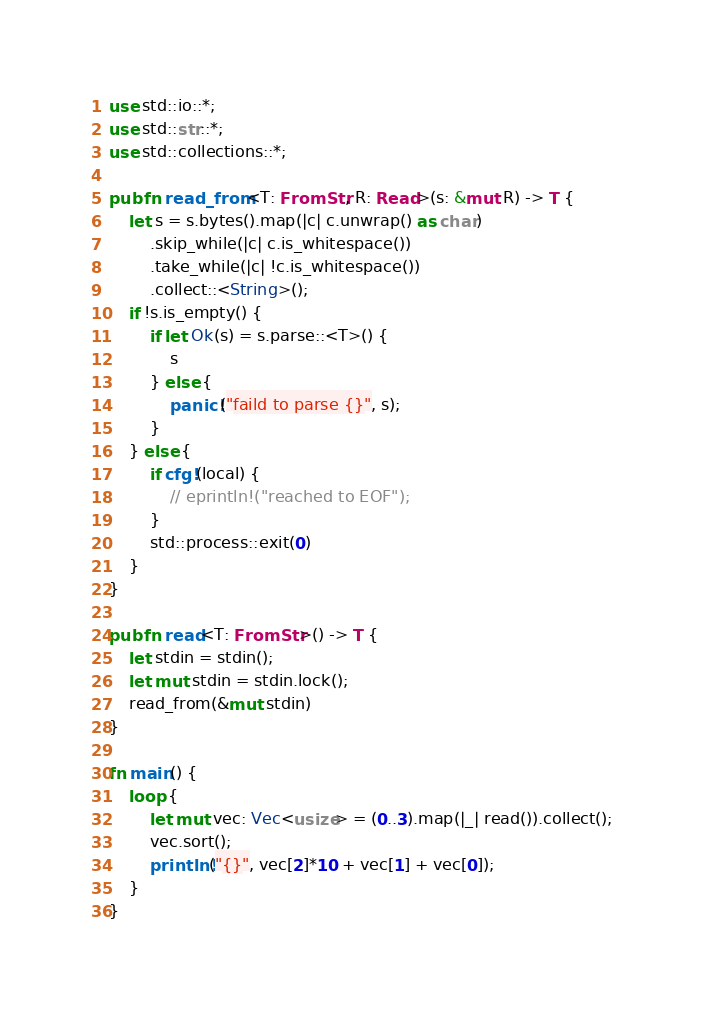Convert code to text. <code><loc_0><loc_0><loc_500><loc_500><_Rust_>use std::io::*;
use std::str::*;
use std::collections::*;

pub fn read_from<T: FromStr, R: Read>(s: &mut R) -> T {
    let s = s.bytes().map(|c| c.unwrap() as char)
        .skip_while(|c| c.is_whitespace())
        .take_while(|c| !c.is_whitespace())
        .collect::<String>();
    if !s.is_empty() {
        if let Ok(s) = s.parse::<T>() {
            s
        } else {
            panic!("faild to parse {}", s);
        }
    } else {
        if cfg!(local) {
            // eprintln!("reached to EOF");
        }
        std::process::exit(0)
    }
}

pub fn read<T: FromStr>() -> T {
    let stdin = stdin();
    let mut stdin = stdin.lock();
    read_from(&mut stdin)
}

fn main() {
    loop {
        let mut vec: Vec<usize> = (0..3).map(|_| read()).collect();
        vec.sort();
        println!("{}", vec[2]*10 + vec[1] + vec[0]);
    }
}
</code> 